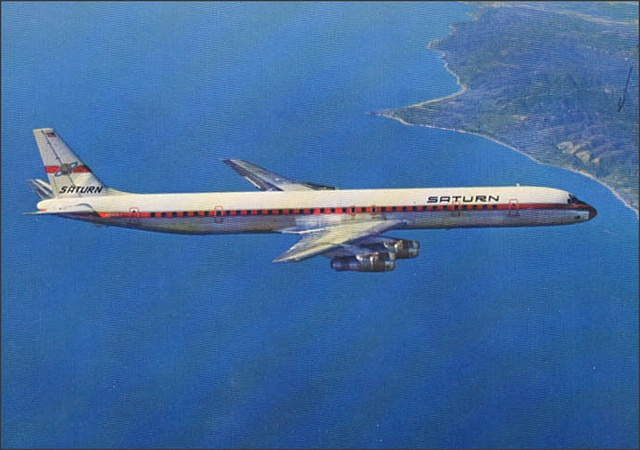Describe the objects in this image and their specific colors. I can see a airplane in black, lightgray, gray, and darkgray tones in this image. 